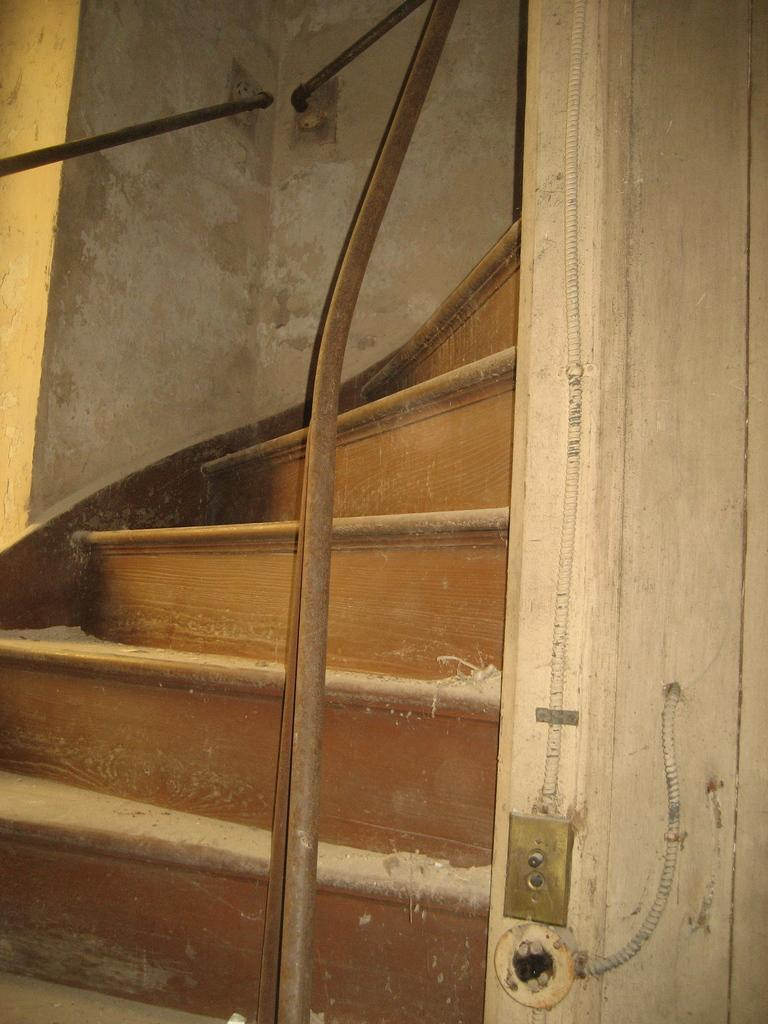What type of structure is present in the image? There are stairs in the image. What can be seen on the left side of the image? There is a wall with iron rods on the left side of the image. What is present on the right side of the image? There appears to be a wall on the right side of the image. Can you see the brain of the person standing on the stairs in the image? There is no person or brain visible in the image; it only features stairs and walls. Can you read the note that the ducks are holding on the stairs in the image? There are no ducks or notes present in the image. 